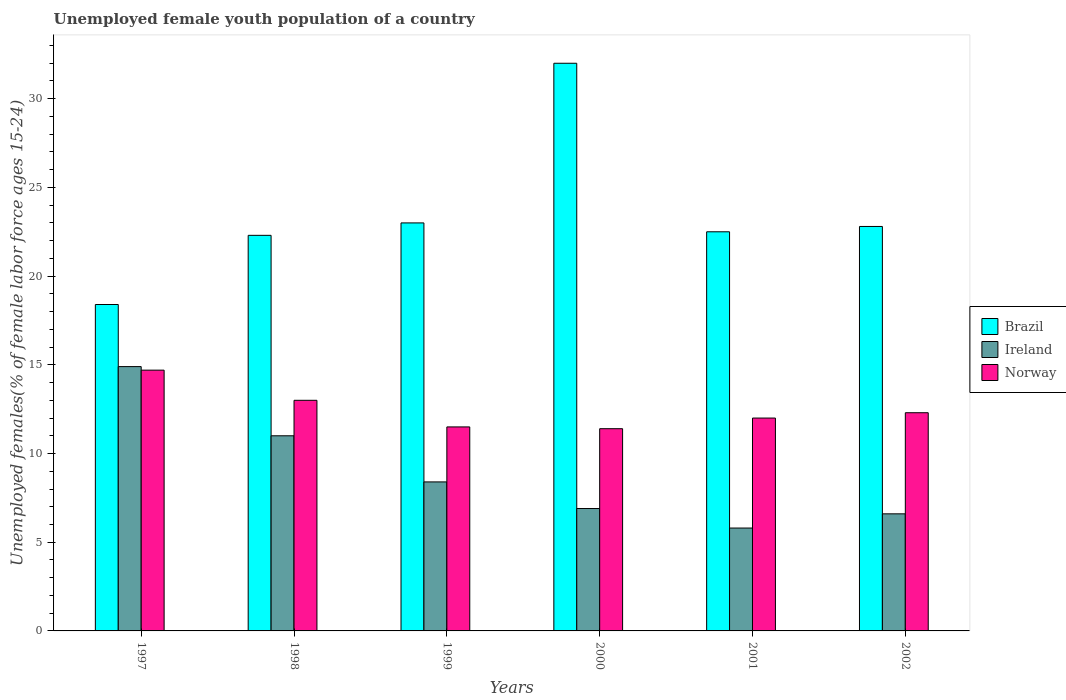Are the number of bars on each tick of the X-axis equal?
Keep it short and to the point. Yes. How many bars are there on the 5th tick from the left?
Make the answer very short. 3. What is the label of the 1st group of bars from the left?
Your answer should be very brief. 1997. What is the percentage of unemployed female youth population in Brazil in 2001?
Your answer should be compact. 22.5. Across all years, what is the maximum percentage of unemployed female youth population in Brazil?
Provide a short and direct response. 32. Across all years, what is the minimum percentage of unemployed female youth population in Norway?
Your answer should be compact. 11.4. In which year was the percentage of unemployed female youth population in Ireland maximum?
Make the answer very short. 1997. In which year was the percentage of unemployed female youth population in Brazil minimum?
Provide a succinct answer. 1997. What is the total percentage of unemployed female youth population in Ireland in the graph?
Provide a short and direct response. 53.6. What is the difference between the percentage of unemployed female youth population in Brazil in 1999 and that in 2002?
Make the answer very short. 0.2. What is the difference between the percentage of unemployed female youth population in Norway in 2002 and the percentage of unemployed female youth population in Brazil in 1999?
Your response must be concise. -10.7. What is the average percentage of unemployed female youth population in Norway per year?
Give a very brief answer. 12.48. In the year 1999, what is the difference between the percentage of unemployed female youth population in Ireland and percentage of unemployed female youth population in Norway?
Give a very brief answer. -3.1. In how many years, is the percentage of unemployed female youth population in Brazil greater than 30 %?
Your answer should be very brief. 1. What is the ratio of the percentage of unemployed female youth population in Norway in 2000 to that in 2002?
Your answer should be very brief. 0.93. What is the difference between the highest and the second highest percentage of unemployed female youth population in Norway?
Make the answer very short. 1.7. What is the difference between the highest and the lowest percentage of unemployed female youth population in Norway?
Your answer should be very brief. 3.3. In how many years, is the percentage of unemployed female youth population in Norway greater than the average percentage of unemployed female youth population in Norway taken over all years?
Offer a very short reply. 2. Is the sum of the percentage of unemployed female youth population in Norway in 2000 and 2002 greater than the maximum percentage of unemployed female youth population in Brazil across all years?
Your response must be concise. No. What does the 3rd bar from the left in 2002 represents?
Offer a terse response. Norway. What does the 2nd bar from the right in 1998 represents?
Ensure brevity in your answer.  Ireland. Is it the case that in every year, the sum of the percentage of unemployed female youth population in Ireland and percentage of unemployed female youth population in Brazil is greater than the percentage of unemployed female youth population in Norway?
Your answer should be very brief. Yes. Are all the bars in the graph horizontal?
Provide a short and direct response. No. How many years are there in the graph?
Ensure brevity in your answer.  6. Are the values on the major ticks of Y-axis written in scientific E-notation?
Your response must be concise. No. Where does the legend appear in the graph?
Provide a short and direct response. Center right. How are the legend labels stacked?
Offer a very short reply. Vertical. What is the title of the graph?
Keep it short and to the point. Unemployed female youth population of a country. Does "Tonga" appear as one of the legend labels in the graph?
Offer a very short reply. No. What is the label or title of the Y-axis?
Offer a very short reply. Unemployed females(% of female labor force ages 15-24). What is the Unemployed females(% of female labor force ages 15-24) of Brazil in 1997?
Your response must be concise. 18.4. What is the Unemployed females(% of female labor force ages 15-24) of Ireland in 1997?
Offer a terse response. 14.9. What is the Unemployed females(% of female labor force ages 15-24) in Norway in 1997?
Provide a succinct answer. 14.7. What is the Unemployed females(% of female labor force ages 15-24) in Brazil in 1998?
Your answer should be very brief. 22.3. What is the Unemployed females(% of female labor force ages 15-24) of Ireland in 1998?
Provide a short and direct response. 11. What is the Unemployed females(% of female labor force ages 15-24) of Norway in 1998?
Keep it short and to the point. 13. What is the Unemployed females(% of female labor force ages 15-24) of Brazil in 1999?
Provide a short and direct response. 23. What is the Unemployed females(% of female labor force ages 15-24) of Ireland in 1999?
Keep it short and to the point. 8.4. What is the Unemployed females(% of female labor force ages 15-24) of Norway in 1999?
Keep it short and to the point. 11.5. What is the Unemployed females(% of female labor force ages 15-24) in Ireland in 2000?
Offer a terse response. 6.9. What is the Unemployed females(% of female labor force ages 15-24) of Norway in 2000?
Offer a terse response. 11.4. What is the Unemployed females(% of female labor force ages 15-24) in Brazil in 2001?
Offer a very short reply. 22.5. What is the Unemployed females(% of female labor force ages 15-24) in Ireland in 2001?
Give a very brief answer. 5.8. What is the Unemployed females(% of female labor force ages 15-24) in Norway in 2001?
Provide a succinct answer. 12. What is the Unemployed females(% of female labor force ages 15-24) of Brazil in 2002?
Provide a short and direct response. 22.8. What is the Unemployed females(% of female labor force ages 15-24) of Ireland in 2002?
Provide a short and direct response. 6.6. What is the Unemployed females(% of female labor force ages 15-24) in Norway in 2002?
Make the answer very short. 12.3. Across all years, what is the maximum Unemployed females(% of female labor force ages 15-24) of Ireland?
Keep it short and to the point. 14.9. Across all years, what is the maximum Unemployed females(% of female labor force ages 15-24) in Norway?
Your answer should be compact. 14.7. Across all years, what is the minimum Unemployed females(% of female labor force ages 15-24) in Brazil?
Ensure brevity in your answer.  18.4. Across all years, what is the minimum Unemployed females(% of female labor force ages 15-24) of Ireland?
Your answer should be very brief. 5.8. Across all years, what is the minimum Unemployed females(% of female labor force ages 15-24) of Norway?
Ensure brevity in your answer.  11.4. What is the total Unemployed females(% of female labor force ages 15-24) of Brazil in the graph?
Offer a terse response. 141. What is the total Unemployed females(% of female labor force ages 15-24) in Ireland in the graph?
Provide a short and direct response. 53.6. What is the total Unemployed females(% of female labor force ages 15-24) in Norway in the graph?
Make the answer very short. 74.9. What is the difference between the Unemployed females(% of female labor force ages 15-24) of Brazil in 1997 and that in 1998?
Provide a short and direct response. -3.9. What is the difference between the Unemployed females(% of female labor force ages 15-24) in Ireland in 1997 and that in 1998?
Offer a very short reply. 3.9. What is the difference between the Unemployed females(% of female labor force ages 15-24) of Norway in 1997 and that in 1998?
Provide a short and direct response. 1.7. What is the difference between the Unemployed females(% of female labor force ages 15-24) in Brazil in 1997 and that in 1999?
Offer a very short reply. -4.6. What is the difference between the Unemployed females(% of female labor force ages 15-24) of Norway in 1997 and that in 1999?
Offer a very short reply. 3.2. What is the difference between the Unemployed females(% of female labor force ages 15-24) in Ireland in 1997 and that in 2000?
Offer a very short reply. 8. What is the difference between the Unemployed females(% of female labor force ages 15-24) in Norway in 1997 and that in 2000?
Make the answer very short. 3.3. What is the difference between the Unemployed females(% of female labor force ages 15-24) of Ireland in 1997 and that in 2002?
Provide a succinct answer. 8.3. What is the difference between the Unemployed females(% of female labor force ages 15-24) of Norway in 1998 and that in 1999?
Give a very brief answer. 1.5. What is the difference between the Unemployed females(% of female labor force ages 15-24) in Brazil in 1998 and that in 2000?
Your response must be concise. -9.7. What is the difference between the Unemployed females(% of female labor force ages 15-24) in Ireland in 1998 and that in 2000?
Ensure brevity in your answer.  4.1. What is the difference between the Unemployed females(% of female labor force ages 15-24) in Norway in 1998 and that in 2000?
Provide a short and direct response. 1.6. What is the difference between the Unemployed females(% of female labor force ages 15-24) of Brazil in 1998 and that in 2002?
Give a very brief answer. -0.5. What is the difference between the Unemployed females(% of female labor force ages 15-24) of Ireland in 1998 and that in 2002?
Provide a short and direct response. 4.4. What is the difference between the Unemployed females(% of female labor force ages 15-24) of Norway in 1998 and that in 2002?
Ensure brevity in your answer.  0.7. What is the difference between the Unemployed females(% of female labor force ages 15-24) of Ireland in 1999 and that in 2000?
Offer a very short reply. 1.5. What is the difference between the Unemployed females(% of female labor force ages 15-24) in Norway in 1999 and that in 2000?
Make the answer very short. 0.1. What is the difference between the Unemployed females(% of female labor force ages 15-24) of Brazil in 1999 and that in 2002?
Keep it short and to the point. 0.2. What is the difference between the Unemployed females(% of female labor force ages 15-24) of Ireland in 1999 and that in 2002?
Provide a succinct answer. 1.8. What is the difference between the Unemployed females(% of female labor force ages 15-24) in Norway in 1999 and that in 2002?
Offer a terse response. -0.8. What is the difference between the Unemployed females(% of female labor force ages 15-24) in Brazil in 2000 and that in 2001?
Provide a short and direct response. 9.5. What is the difference between the Unemployed females(% of female labor force ages 15-24) in Norway in 2000 and that in 2001?
Offer a very short reply. -0.6. What is the difference between the Unemployed females(% of female labor force ages 15-24) of Brazil in 2000 and that in 2002?
Your response must be concise. 9.2. What is the difference between the Unemployed females(% of female labor force ages 15-24) of Ireland in 2000 and that in 2002?
Ensure brevity in your answer.  0.3. What is the difference between the Unemployed females(% of female labor force ages 15-24) in Norway in 2000 and that in 2002?
Offer a terse response. -0.9. What is the difference between the Unemployed females(% of female labor force ages 15-24) in Brazil in 2001 and that in 2002?
Offer a terse response. -0.3. What is the difference between the Unemployed females(% of female labor force ages 15-24) of Norway in 2001 and that in 2002?
Offer a very short reply. -0.3. What is the difference between the Unemployed females(% of female labor force ages 15-24) in Brazil in 1997 and the Unemployed females(% of female labor force ages 15-24) in Ireland in 1998?
Ensure brevity in your answer.  7.4. What is the difference between the Unemployed females(% of female labor force ages 15-24) in Ireland in 1997 and the Unemployed females(% of female labor force ages 15-24) in Norway in 1998?
Provide a short and direct response. 1.9. What is the difference between the Unemployed females(% of female labor force ages 15-24) in Ireland in 1997 and the Unemployed females(% of female labor force ages 15-24) in Norway in 1999?
Your answer should be compact. 3.4. What is the difference between the Unemployed females(% of female labor force ages 15-24) of Brazil in 1997 and the Unemployed females(% of female labor force ages 15-24) of Ireland in 2000?
Provide a succinct answer. 11.5. What is the difference between the Unemployed females(% of female labor force ages 15-24) in Brazil in 1997 and the Unemployed females(% of female labor force ages 15-24) in Ireland in 2002?
Provide a succinct answer. 11.8. What is the difference between the Unemployed females(% of female labor force ages 15-24) of Ireland in 1997 and the Unemployed females(% of female labor force ages 15-24) of Norway in 2002?
Give a very brief answer. 2.6. What is the difference between the Unemployed females(% of female labor force ages 15-24) in Brazil in 1998 and the Unemployed females(% of female labor force ages 15-24) in Ireland in 1999?
Provide a succinct answer. 13.9. What is the difference between the Unemployed females(% of female labor force ages 15-24) of Ireland in 1998 and the Unemployed females(% of female labor force ages 15-24) of Norway in 1999?
Provide a short and direct response. -0.5. What is the difference between the Unemployed females(% of female labor force ages 15-24) of Brazil in 1998 and the Unemployed females(% of female labor force ages 15-24) of Norway in 2000?
Your response must be concise. 10.9. What is the difference between the Unemployed females(% of female labor force ages 15-24) in Brazil in 1998 and the Unemployed females(% of female labor force ages 15-24) in Ireland in 2001?
Give a very brief answer. 16.5. What is the difference between the Unemployed females(% of female labor force ages 15-24) in Brazil in 1998 and the Unemployed females(% of female labor force ages 15-24) in Ireland in 2002?
Ensure brevity in your answer.  15.7. What is the difference between the Unemployed females(% of female labor force ages 15-24) of Ireland in 1999 and the Unemployed females(% of female labor force ages 15-24) of Norway in 2000?
Your response must be concise. -3. What is the difference between the Unemployed females(% of female labor force ages 15-24) of Brazil in 1999 and the Unemployed females(% of female labor force ages 15-24) of Norway in 2001?
Make the answer very short. 11. What is the difference between the Unemployed females(% of female labor force ages 15-24) in Brazil in 1999 and the Unemployed females(% of female labor force ages 15-24) in Ireland in 2002?
Keep it short and to the point. 16.4. What is the difference between the Unemployed females(% of female labor force ages 15-24) of Brazil in 2000 and the Unemployed females(% of female labor force ages 15-24) of Ireland in 2001?
Ensure brevity in your answer.  26.2. What is the difference between the Unemployed females(% of female labor force ages 15-24) in Brazil in 2000 and the Unemployed females(% of female labor force ages 15-24) in Norway in 2001?
Provide a short and direct response. 20. What is the difference between the Unemployed females(% of female labor force ages 15-24) in Brazil in 2000 and the Unemployed females(% of female labor force ages 15-24) in Ireland in 2002?
Offer a very short reply. 25.4. What is the difference between the Unemployed females(% of female labor force ages 15-24) of Brazil in 2000 and the Unemployed females(% of female labor force ages 15-24) of Norway in 2002?
Your response must be concise. 19.7. What is the difference between the Unemployed females(% of female labor force ages 15-24) of Ireland in 2000 and the Unemployed females(% of female labor force ages 15-24) of Norway in 2002?
Offer a terse response. -5.4. What is the difference between the Unemployed females(% of female labor force ages 15-24) in Brazil in 2001 and the Unemployed females(% of female labor force ages 15-24) in Norway in 2002?
Keep it short and to the point. 10.2. What is the average Unemployed females(% of female labor force ages 15-24) in Ireland per year?
Give a very brief answer. 8.93. What is the average Unemployed females(% of female labor force ages 15-24) of Norway per year?
Your answer should be very brief. 12.48. In the year 1998, what is the difference between the Unemployed females(% of female labor force ages 15-24) in Brazil and Unemployed females(% of female labor force ages 15-24) in Ireland?
Make the answer very short. 11.3. In the year 1998, what is the difference between the Unemployed females(% of female labor force ages 15-24) of Brazil and Unemployed females(% of female labor force ages 15-24) of Norway?
Give a very brief answer. 9.3. In the year 1999, what is the difference between the Unemployed females(% of female labor force ages 15-24) in Ireland and Unemployed females(% of female labor force ages 15-24) in Norway?
Your answer should be compact. -3.1. In the year 2000, what is the difference between the Unemployed females(% of female labor force ages 15-24) of Brazil and Unemployed females(% of female labor force ages 15-24) of Ireland?
Ensure brevity in your answer.  25.1. In the year 2000, what is the difference between the Unemployed females(% of female labor force ages 15-24) in Brazil and Unemployed females(% of female labor force ages 15-24) in Norway?
Provide a succinct answer. 20.6. In the year 2001, what is the difference between the Unemployed females(% of female labor force ages 15-24) of Brazil and Unemployed females(% of female labor force ages 15-24) of Ireland?
Offer a very short reply. 16.7. In the year 2001, what is the difference between the Unemployed females(% of female labor force ages 15-24) in Ireland and Unemployed females(% of female labor force ages 15-24) in Norway?
Keep it short and to the point. -6.2. In the year 2002, what is the difference between the Unemployed females(% of female labor force ages 15-24) in Brazil and Unemployed females(% of female labor force ages 15-24) in Ireland?
Ensure brevity in your answer.  16.2. In the year 2002, what is the difference between the Unemployed females(% of female labor force ages 15-24) of Ireland and Unemployed females(% of female labor force ages 15-24) of Norway?
Your answer should be compact. -5.7. What is the ratio of the Unemployed females(% of female labor force ages 15-24) in Brazil in 1997 to that in 1998?
Provide a succinct answer. 0.83. What is the ratio of the Unemployed females(% of female labor force ages 15-24) in Ireland in 1997 to that in 1998?
Ensure brevity in your answer.  1.35. What is the ratio of the Unemployed females(% of female labor force ages 15-24) of Norway in 1997 to that in 1998?
Ensure brevity in your answer.  1.13. What is the ratio of the Unemployed females(% of female labor force ages 15-24) of Ireland in 1997 to that in 1999?
Your answer should be very brief. 1.77. What is the ratio of the Unemployed females(% of female labor force ages 15-24) of Norway in 1997 to that in 1999?
Provide a short and direct response. 1.28. What is the ratio of the Unemployed females(% of female labor force ages 15-24) of Brazil in 1997 to that in 2000?
Ensure brevity in your answer.  0.57. What is the ratio of the Unemployed females(% of female labor force ages 15-24) of Ireland in 1997 to that in 2000?
Make the answer very short. 2.16. What is the ratio of the Unemployed females(% of female labor force ages 15-24) in Norway in 1997 to that in 2000?
Offer a very short reply. 1.29. What is the ratio of the Unemployed females(% of female labor force ages 15-24) of Brazil in 1997 to that in 2001?
Offer a very short reply. 0.82. What is the ratio of the Unemployed females(% of female labor force ages 15-24) in Ireland in 1997 to that in 2001?
Offer a very short reply. 2.57. What is the ratio of the Unemployed females(% of female labor force ages 15-24) in Norway in 1997 to that in 2001?
Make the answer very short. 1.23. What is the ratio of the Unemployed females(% of female labor force ages 15-24) in Brazil in 1997 to that in 2002?
Offer a terse response. 0.81. What is the ratio of the Unemployed females(% of female labor force ages 15-24) of Ireland in 1997 to that in 2002?
Your answer should be compact. 2.26. What is the ratio of the Unemployed females(% of female labor force ages 15-24) in Norway in 1997 to that in 2002?
Make the answer very short. 1.2. What is the ratio of the Unemployed females(% of female labor force ages 15-24) in Brazil in 1998 to that in 1999?
Your answer should be very brief. 0.97. What is the ratio of the Unemployed females(% of female labor force ages 15-24) of Ireland in 1998 to that in 1999?
Offer a very short reply. 1.31. What is the ratio of the Unemployed females(% of female labor force ages 15-24) in Norway in 1998 to that in 1999?
Keep it short and to the point. 1.13. What is the ratio of the Unemployed females(% of female labor force ages 15-24) in Brazil in 1998 to that in 2000?
Offer a very short reply. 0.7. What is the ratio of the Unemployed females(% of female labor force ages 15-24) of Ireland in 1998 to that in 2000?
Provide a short and direct response. 1.59. What is the ratio of the Unemployed females(% of female labor force ages 15-24) in Norway in 1998 to that in 2000?
Keep it short and to the point. 1.14. What is the ratio of the Unemployed females(% of female labor force ages 15-24) of Brazil in 1998 to that in 2001?
Your response must be concise. 0.99. What is the ratio of the Unemployed females(% of female labor force ages 15-24) of Ireland in 1998 to that in 2001?
Your response must be concise. 1.9. What is the ratio of the Unemployed females(% of female labor force ages 15-24) in Brazil in 1998 to that in 2002?
Provide a short and direct response. 0.98. What is the ratio of the Unemployed females(% of female labor force ages 15-24) in Ireland in 1998 to that in 2002?
Ensure brevity in your answer.  1.67. What is the ratio of the Unemployed females(% of female labor force ages 15-24) in Norway in 1998 to that in 2002?
Keep it short and to the point. 1.06. What is the ratio of the Unemployed females(% of female labor force ages 15-24) of Brazil in 1999 to that in 2000?
Offer a terse response. 0.72. What is the ratio of the Unemployed females(% of female labor force ages 15-24) in Ireland in 1999 to that in 2000?
Give a very brief answer. 1.22. What is the ratio of the Unemployed females(% of female labor force ages 15-24) of Norway in 1999 to that in 2000?
Offer a very short reply. 1.01. What is the ratio of the Unemployed females(% of female labor force ages 15-24) of Brazil in 1999 to that in 2001?
Provide a short and direct response. 1.02. What is the ratio of the Unemployed females(% of female labor force ages 15-24) in Ireland in 1999 to that in 2001?
Your response must be concise. 1.45. What is the ratio of the Unemployed females(% of female labor force ages 15-24) in Norway in 1999 to that in 2001?
Your answer should be very brief. 0.96. What is the ratio of the Unemployed females(% of female labor force ages 15-24) in Brazil in 1999 to that in 2002?
Provide a short and direct response. 1.01. What is the ratio of the Unemployed females(% of female labor force ages 15-24) of Ireland in 1999 to that in 2002?
Keep it short and to the point. 1.27. What is the ratio of the Unemployed females(% of female labor force ages 15-24) in Norway in 1999 to that in 2002?
Ensure brevity in your answer.  0.94. What is the ratio of the Unemployed females(% of female labor force ages 15-24) of Brazil in 2000 to that in 2001?
Your answer should be very brief. 1.42. What is the ratio of the Unemployed females(% of female labor force ages 15-24) in Ireland in 2000 to that in 2001?
Your answer should be very brief. 1.19. What is the ratio of the Unemployed females(% of female labor force ages 15-24) in Norway in 2000 to that in 2001?
Offer a terse response. 0.95. What is the ratio of the Unemployed females(% of female labor force ages 15-24) of Brazil in 2000 to that in 2002?
Make the answer very short. 1.4. What is the ratio of the Unemployed females(% of female labor force ages 15-24) of Ireland in 2000 to that in 2002?
Offer a very short reply. 1.05. What is the ratio of the Unemployed females(% of female labor force ages 15-24) in Norway in 2000 to that in 2002?
Ensure brevity in your answer.  0.93. What is the ratio of the Unemployed females(% of female labor force ages 15-24) of Ireland in 2001 to that in 2002?
Give a very brief answer. 0.88. What is the ratio of the Unemployed females(% of female labor force ages 15-24) of Norway in 2001 to that in 2002?
Provide a succinct answer. 0.98. What is the difference between the highest and the second highest Unemployed females(% of female labor force ages 15-24) of Brazil?
Your answer should be very brief. 9. What is the difference between the highest and the lowest Unemployed females(% of female labor force ages 15-24) of Ireland?
Provide a succinct answer. 9.1. What is the difference between the highest and the lowest Unemployed females(% of female labor force ages 15-24) in Norway?
Offer a terse response. 3.3. 